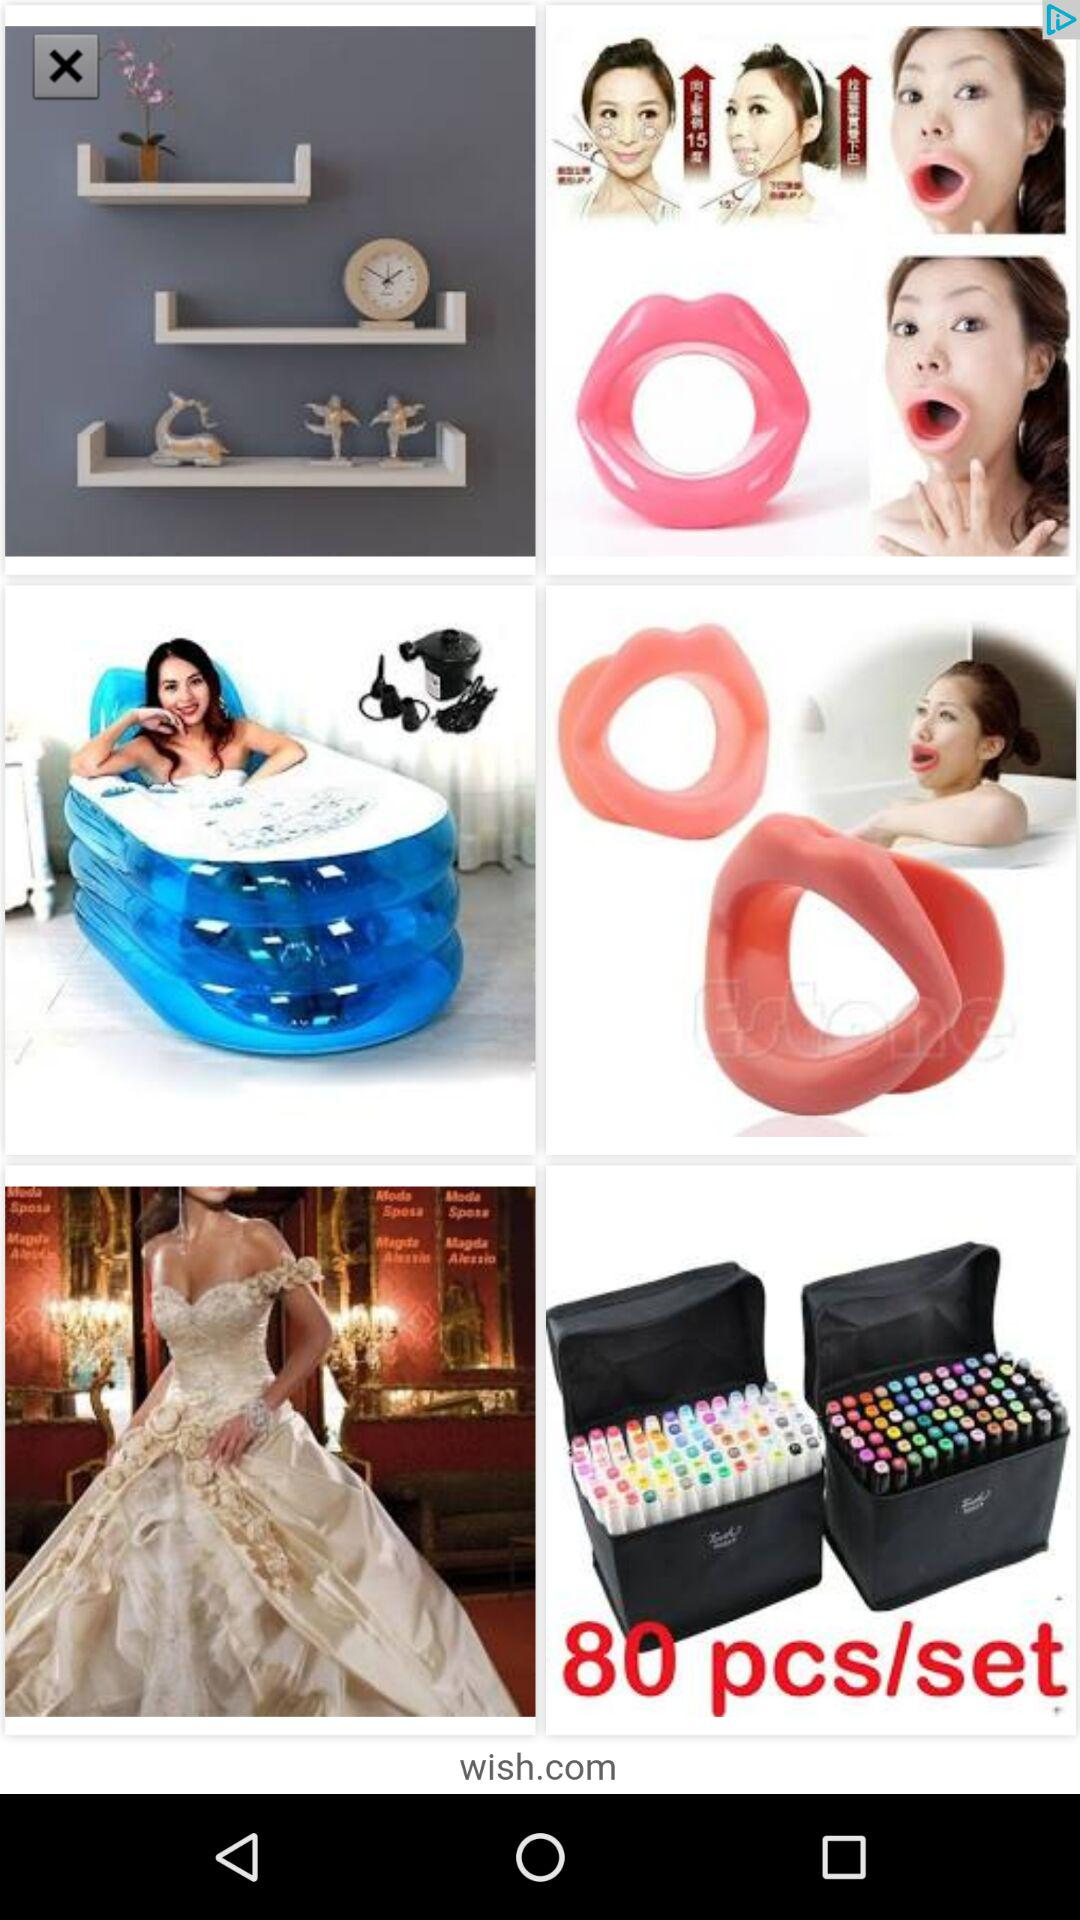How many pieces are in the set? There are 80 pieces in the set. 